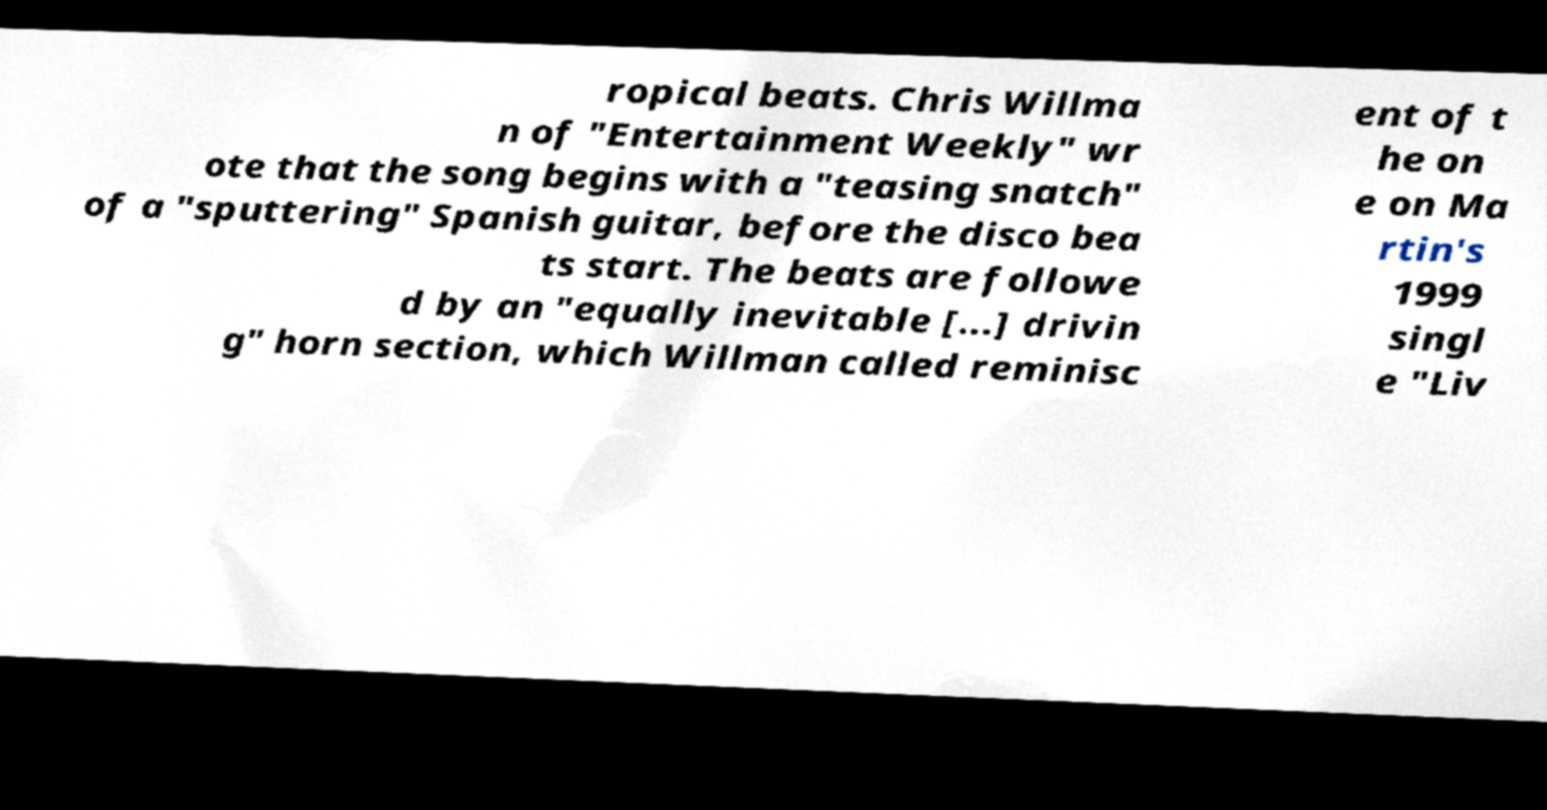Can you accurately transcribe the text from the provided image for me? ropical beats. Chris Willma n of "Entertainment Weekly" wr ote that the song begins with a "teasing snatch" of a "sputtering" Spanish guitar, before the disco bea ts start. The beats are followe d by an "equally inevitable [...] drivin g" horn section, which Willman called reminisc ent of t he on e on Ma rtin's 1999 singl e "Liv 